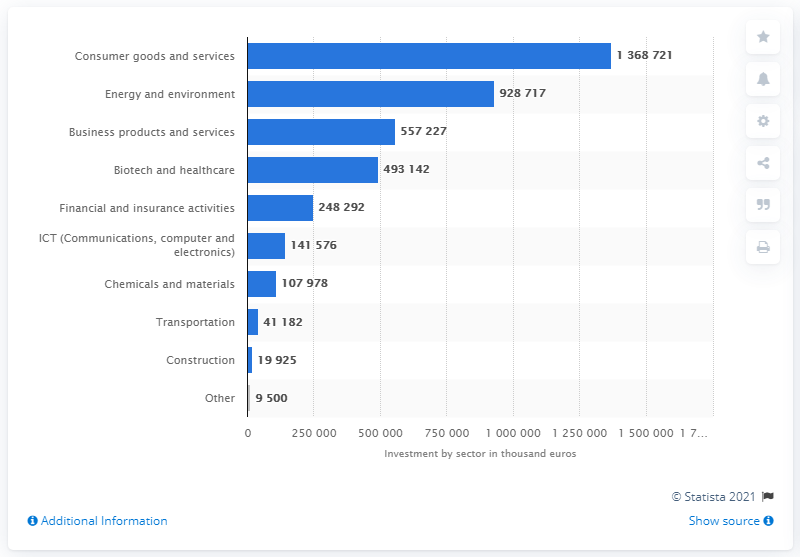Indicate a few pertinent items in this graphic. In the year 2021, the value of private equity investments in consumer goods and services was approximately 136,872,100. 